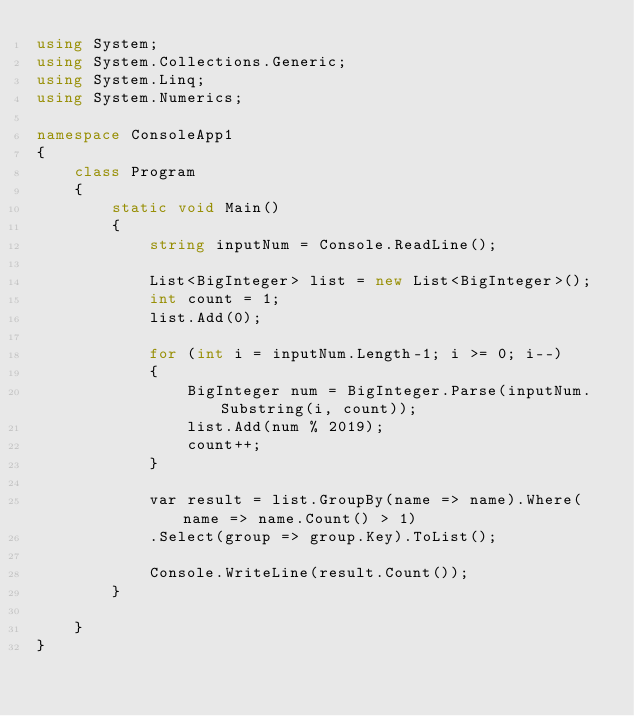Convert code to text. <code><loc_0><loc_0><loc_500><loc_500><_C#_>using System;
using System.Collections.Generic;
using System.Linq;
using System.Numerics;

namespace ConsoleApp1
{
    class Program
    {
        static void Main()
        {
            string inputNum = Console.ReadLine();

            List<BigInteger> list = new List<BigInteger>();
            int count = 1;
            list.Add(0);

            for (int i = inputNum.Length-1; i >= 0; i--)
            {
                BigInteger num = BigInteger.Parse(inputNum.Substring(i, count));
                list.Add(num % 2019);
                count++;
            }

            var result = list.GroupBy(name => name).Where(name => name.Count() > 1)
            .Select(group => group.Key).ToList();

            Console.WriteLine(result.Count());
        }

    }
}
</code> 